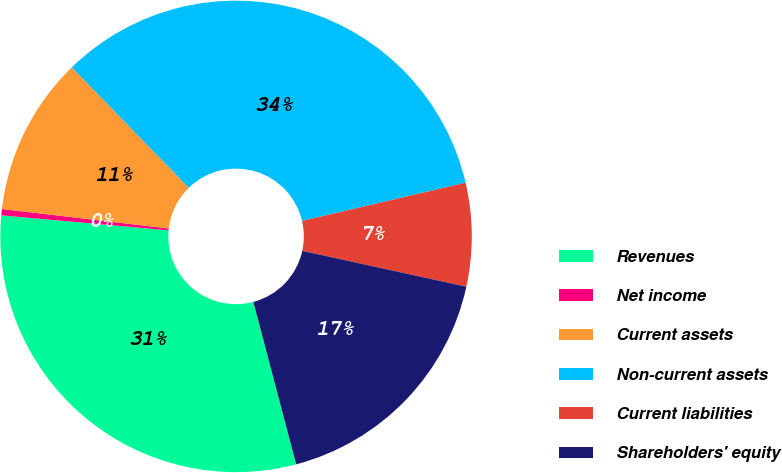Convert chart. <chart><loc_0><loc_0><loc_500><loc_500><pie_chart><fcel>Revenues<fcel>Net income<fcel>Current assets<fcel>Non-current assets<fcel>Current liabilities<fcel>Shareholders' equity<nl><fcel>30.53%<fcel>0.43%<fcel>10.87%<fcel>33.62%<fcel>7.08%<fcel>17.47%<nl></chart> 